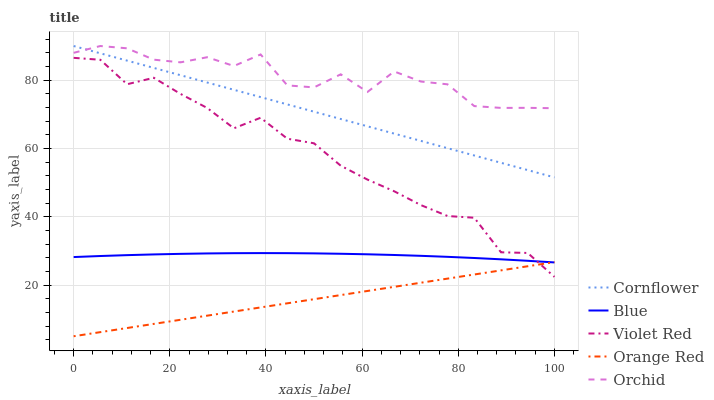Does Orange Red have the minimum area under the curve?
Answer yes or no. Yes. Does Orchid have the maximum area under the curve?
Answer yes or no. Yes. Does Cornflower have the minimum area under the curve?
Answer yes or no. No. Does Cornflower have the maximum area under the curve?
Answer yes or no. No. Is Orange Red the smoothest?
Answer yes or no. Yes. Is Orchid the roughest?
Answer yes or no. Yes. Is Cornflower the smoothest?
Answer yes or no. No. Is Cornflower the roughest?
Answer yes or no. No. Does Cornflower have the lowest value?
Answer yes or no. No. Does Orchid have the highest value?
Answer yes or no. Yes. Does Violet Red have the highest value?
Answer yes or no. No. Is Blue less than Orchid?
Answer yes or no. Yes. Is Orchid greater than Orange Red?
Answer yes or no. Yes. Does Orchid intersect Cornflower?
Answer yes or no. Yes. Is Orchid less than Cornflower?
Answer yes or no. No. Is Orchid greater than Cornflower?
Answer yes or no. No. Does Blue intersect Orchid?
Answer yes or no. No. 